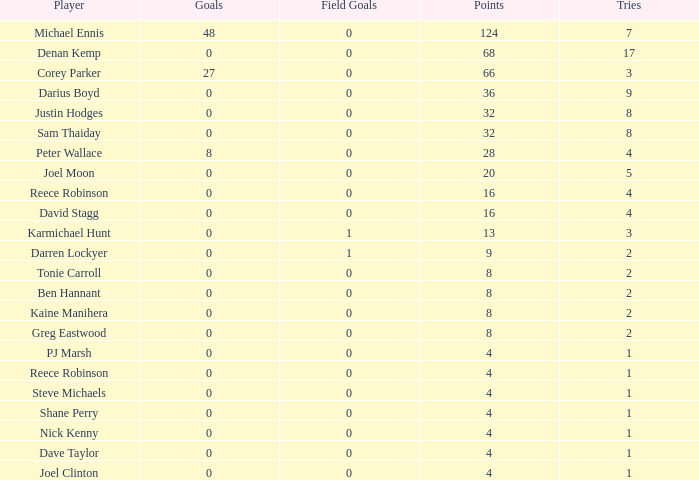What is the total number of field goals of Denan Kemp, who has more than 4 tries, more than 32 points, and 0 goals? 1.0. 